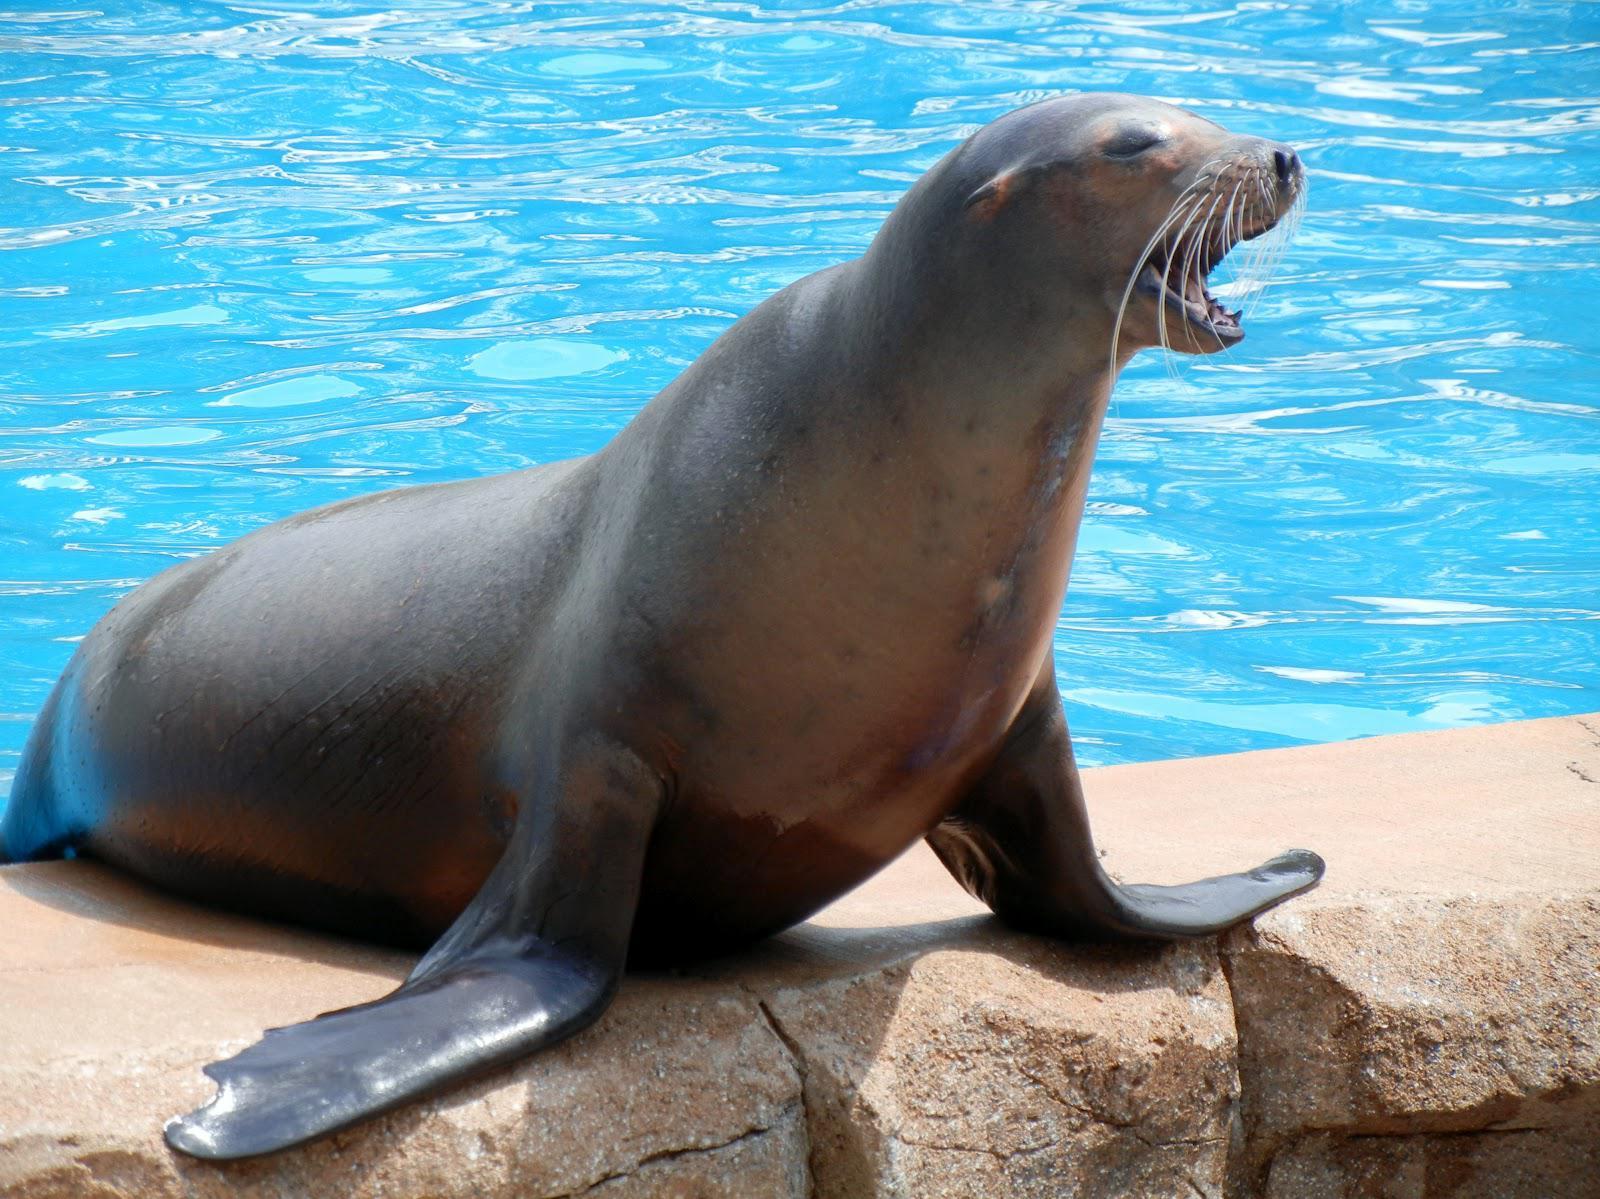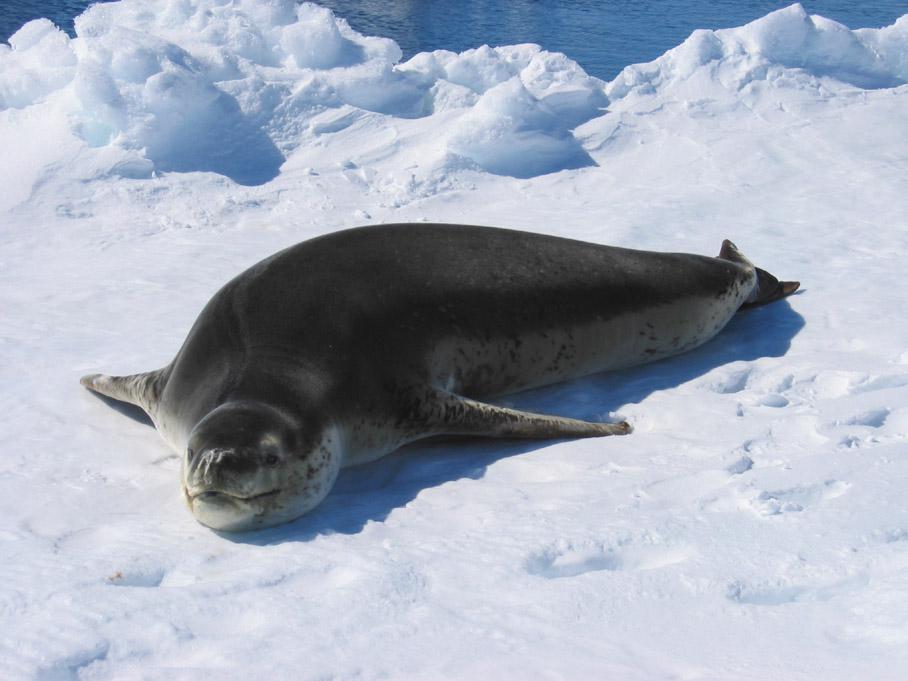The first image is the image on the left, the second image is the image on the right. Given the left and right images, does the statement "There are two seals in total." hold true? Answer yes or no. Yes. The first image is the image on the left, the second image is the image on the right. Considering the images on both sides, is "An image shows exactly one seal on a manmade structure next to a blue pool." valid? Answer yes or no. Yes. 